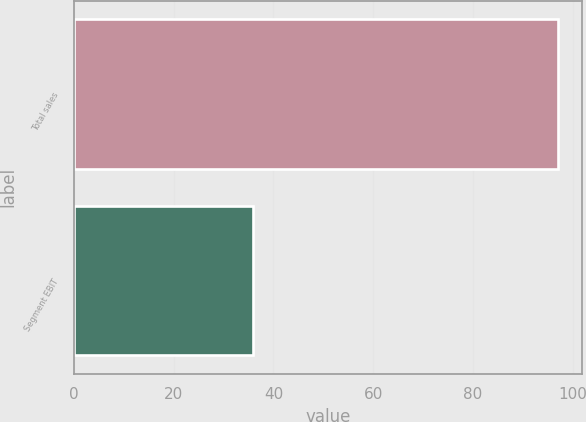<chart> <loc_0><loc_0><loc_500><loc_500><bar_chart><fcel>Total sales<fcel>Segment EBIT<nl><fcel>97<fcel>36<nl></chart> 